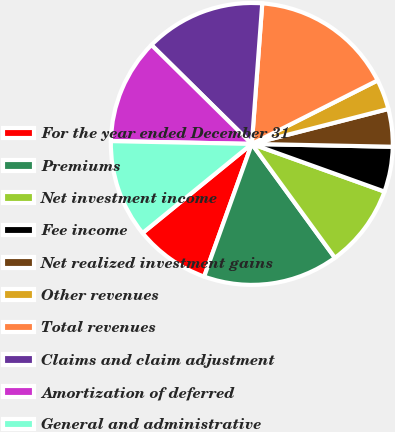Convert chart to OTSL. <chart><loc_0><loc_0><loc_500><loc_500><pie_chart><fcel>For the year ended December 31<fcel>Premiums<fcel>Net investment income<fcel>Fee income<fcel>Net realized investment gains<fcel>Other revenues<fcel>Total revenues<fcel>Claims and claim adjustment<fcel>Amortization of deferred<fcel>General and administrative<nl><fcel>8.62%<fcel>15.52%<fcel>9.48%<fcel>5.17%<fcel>4.31%<fcel>3.45%<fcel>16.38%<fcel>13.79%<fcel>12.07%<fcel>11.21%<nl></chart> 